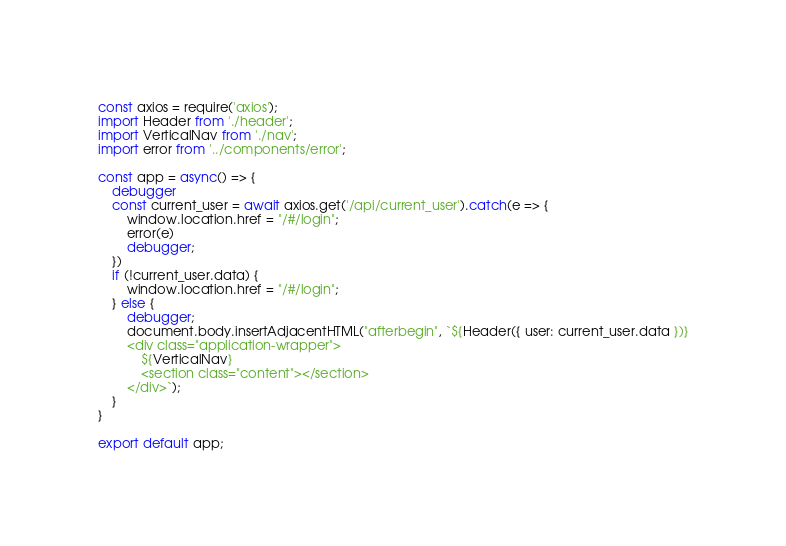<code> <loc_0><loc_0><loc_500><loc_500><_JavaScript_>const axios = require('axios');
import Header from './header';
import VerticalNav from './nav';
import error from '../components/error';

const app = async() => {
    debugger
    const current_user = await axios.get('/api/current_user').catch(e => {
        window.location.href = "/#/login";
        error(e)
        debugger;
    })
    if (!current_user.data) {
        window.location.href = "/#/login";
    } else {
        debugger;
        document.body.insertAdjacentHTML("afterbegin", `${Header({ user: current_user.data })}
        <div class="application-wrapper"> 
            ${VerticalNav}
            <section class="content"></section>
        </div>`);
    }
}

export default app;</code> 